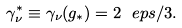<formula> <loc_0><loc_0><loc_500><loc_500>\gamma _ { \nu } ^ { * } \equiv \gamma _ { \nu } ( g _ { * } ) = 2 \ e p s / 3 .</formula> 